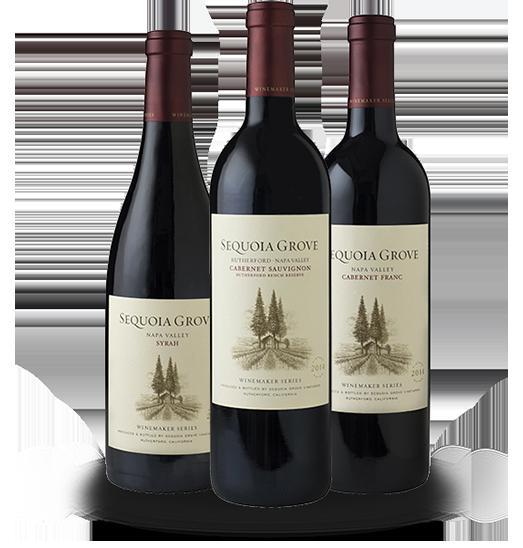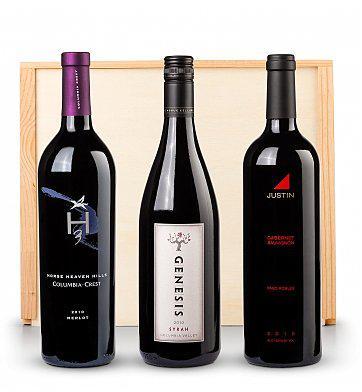The first image is the image on the left, the second image is the image on the right. Analyze the images presented: Is the assertion "An image shows a horizontal row of exactly three wine bottles, and the bottle on the left has a gold wrap over the cap." valid? Answer yes or no. No. The first image is the image on the left, the second image is the image on the right. For the images shown, is this caption "There are three wine bottles against a plain white background in each image." true? Answer yes or no. No. 